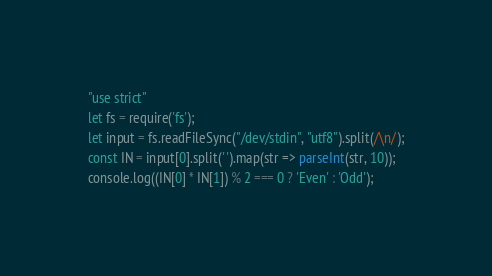<code> <loc_0><loc_0><loc_500><loc_500><_TypeScript_>"use strict"
let fs = require('fs');
let input = fs.readFileSync("/dev/stdin", "utf8").split(/\n/);
const IN = input[0].split(' ').map(str => parseInt(str, 10));
console.log((IN[0] * IN[1]) % 2 === 0 ? 'Even' : 'Odd');</code> 